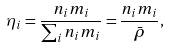Convert formula to latex. <formula><loc_0><loc_0><loc_500><loc_500>\eta _ { i } = \frac { n _ { i } m _ { i } } { \sum _ { i } n _ { i } m _ { i } } = \frac { n _ { i } m _ { i } } { \bar { \rho } } ,</formula> 